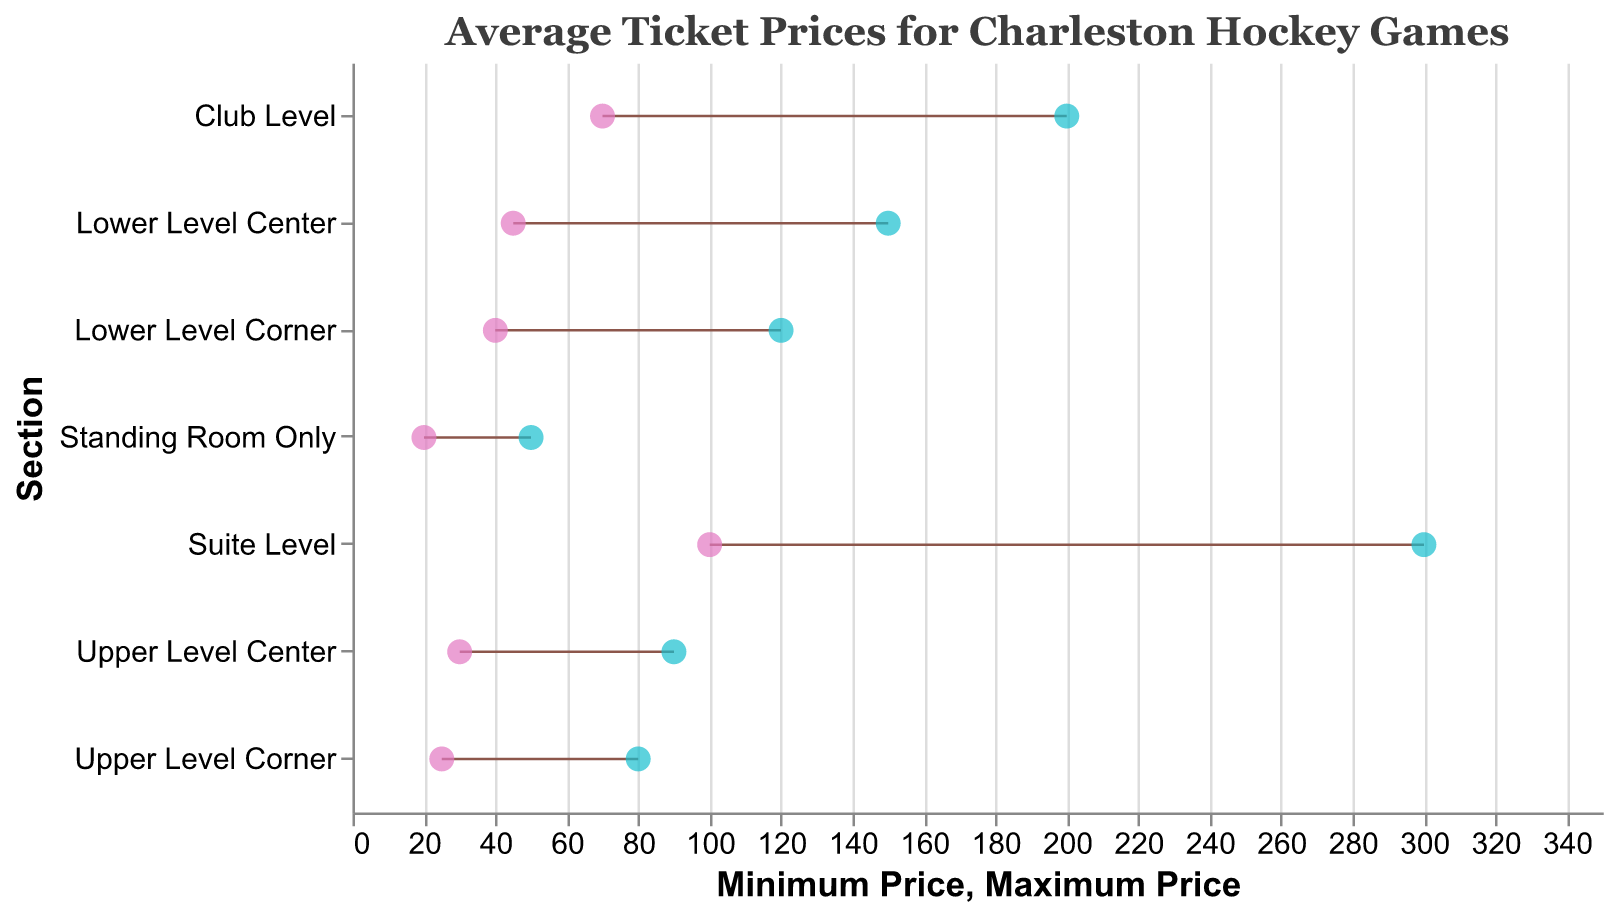What is the minimum price for a ticket in the Suite Level section? From the figure, identify the minimum price for the "Suite Level" section. According to the data provided, the minimum price for Suite Level is $100.
Answer: $100 Which section has the highest maximum ticket price? Look for the section with the highest value on the "Maximum Price" point. The Suite Level has the highest maximum ticket price at $300.
Answer: Suite Level What is the price range for tickets in the Upper Level Corner section? Subtract the minimum price from the maximum price for the "Upper Level Corner" section. The maximum price is $80 and the minimum price is $25, so the range is $80 - $25 = $55.
Answer: $55 Which section has the narrowest price range? Calculate the range for each section by subtracting the minimum price from the maximum price. The section with the smallest range will be "Standing Room Only" with a range of $50 - $20 = $30.
Answer: Standing Room Only How do the minimum prices for the Lower Level Corner and Club Level sections compare? Compare the minimum price values for both sections. The Lower Level Corner has a minimum price of $40 and the Club Level has a minimum price of $70, so the Club Level is more expensive.
Answer: Club Level is more expensive What is the difference between the maximum prices of the Lower Level Center and Upper Level Center sections? Subtract the maximum price of the Upper Level Center section from the maximum price of the Lower Level Center section. $150 - $90 = $60.
Answer: $60 Which section provides the most price variability? Look for the section with the largest difference between its minimum and maximum prices. Suite Level has the largest variability with $300 - $100 = $200.
Answer: Suite Level For which section is the minimum price the same as the maximum price minus $30? Check for the sections where this condition holds true. For "Standing Room Only," the minimum price is $20, and the maximum price is $50. $50 - $30 = $20, so Standing Room Only meets the condition.
Answer: Standing Room Only What is the average of the maximum prices for the Lower Level Corner and Club Level sections? Add the maximum prices of the Lower Level Corner and Club Level sections and divide by 2. ($120 + $200) / 2 = $160.
Answer: $160 